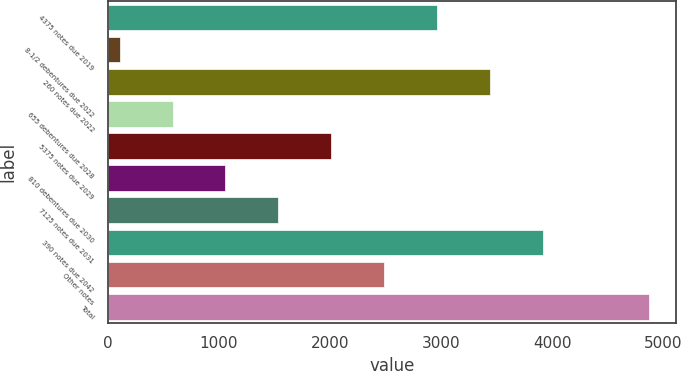Convert chart. <chart><loc_0><loc_0><loc_500><loc_500><bar_chart><fcel>4375 notes due 2019<fcel>8-1/2 debentures due 2022<fcel>260 notes due 2022<fcel>655 debentures due 2028<fcel>5375 notes due 2029<fcel>810 debentures due 2030<fcel>7125 notes due 2031<fcel>390 notes due 2042<fcel>Other notes<fcel>Total<nl><fcel>2964.6<fcel>105<fcel>3441.2<fcel>581.6<fcel>2011.4<fcel>1058.2<fcel>1534.8<fcel>3917.8<fcel>2488<fcel>4871<nl></chart> 